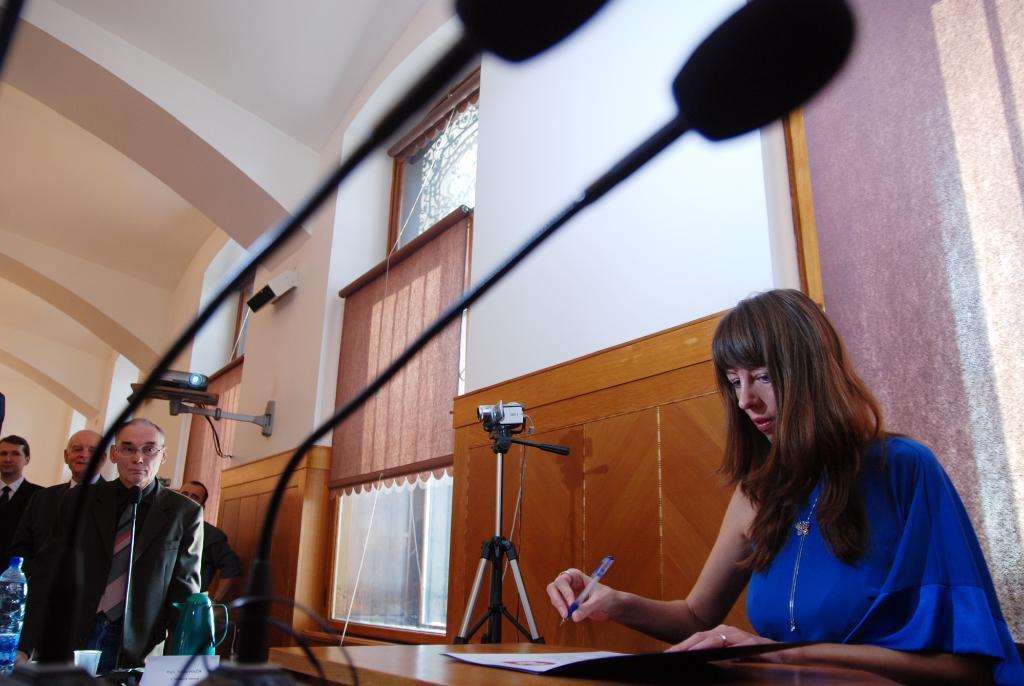Could you give a brief overview of what you see in this image? In this image there is a lady sitting beside the table and holding a pen and on the table there is a book, there are a few people, microphones, a camera to the camera stand, a bottle, glass and a plastic jar on the other table, few windows and window cloths rolled into a stick and the threads attached to the sticks. 